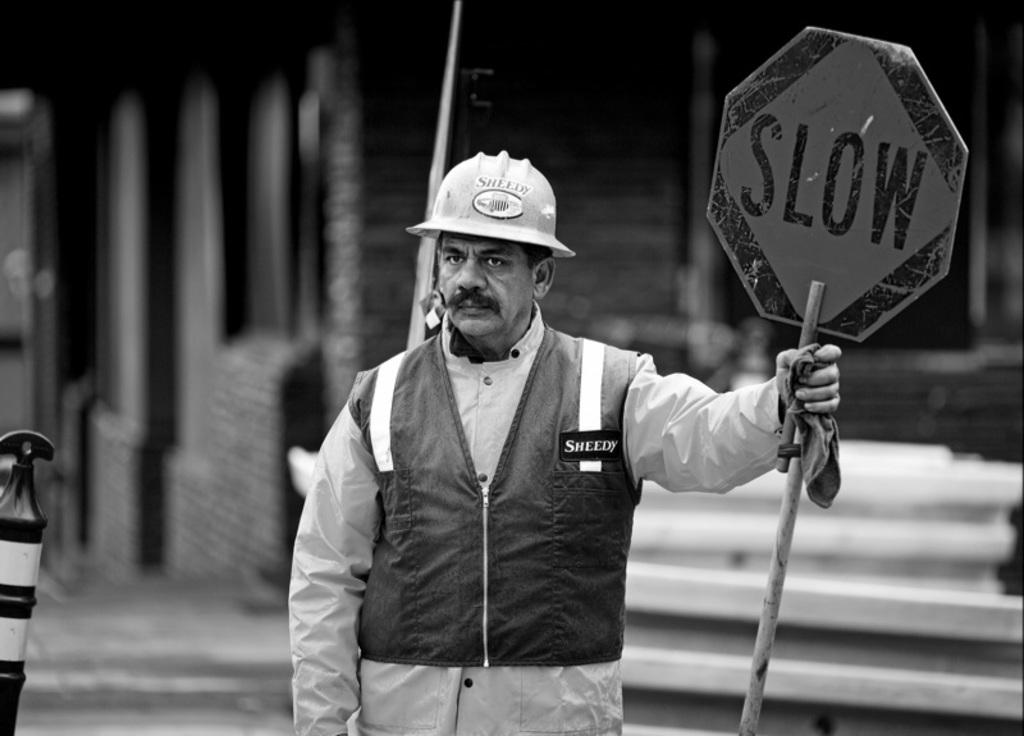What is the man in the image doing? The man is standing and watching a pole with a board. What is on the pole that the man is watching? There is a board on the pole. Can you describe the possible background in the image? There may be a house behind the man. What type of day is it in the image? The provided facts do not mention the weather or time of day, so it is impossible to determine the type of day in the image. 